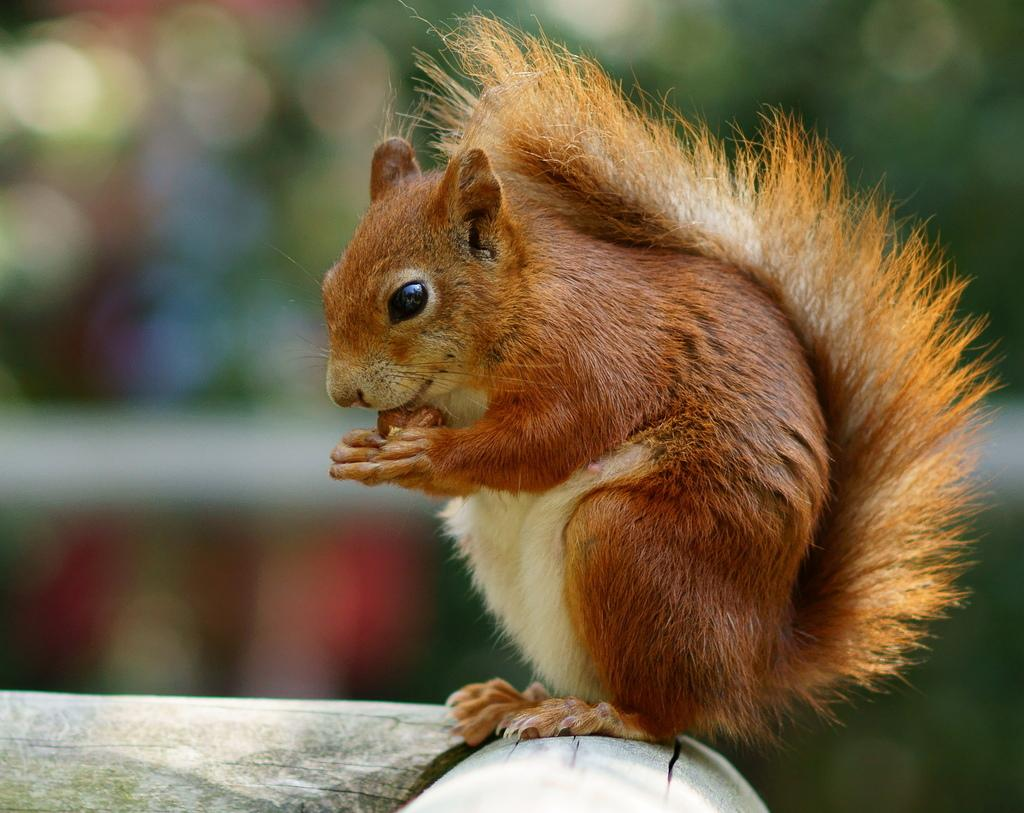What type of animal is in the image? There is a squirrel in the image. Can you describe the background of the image? The background of the image is blurry. What is the value of the ticket held by the squirrel in the image? There is no ticket present in the image, and therefore no value can be determined. 